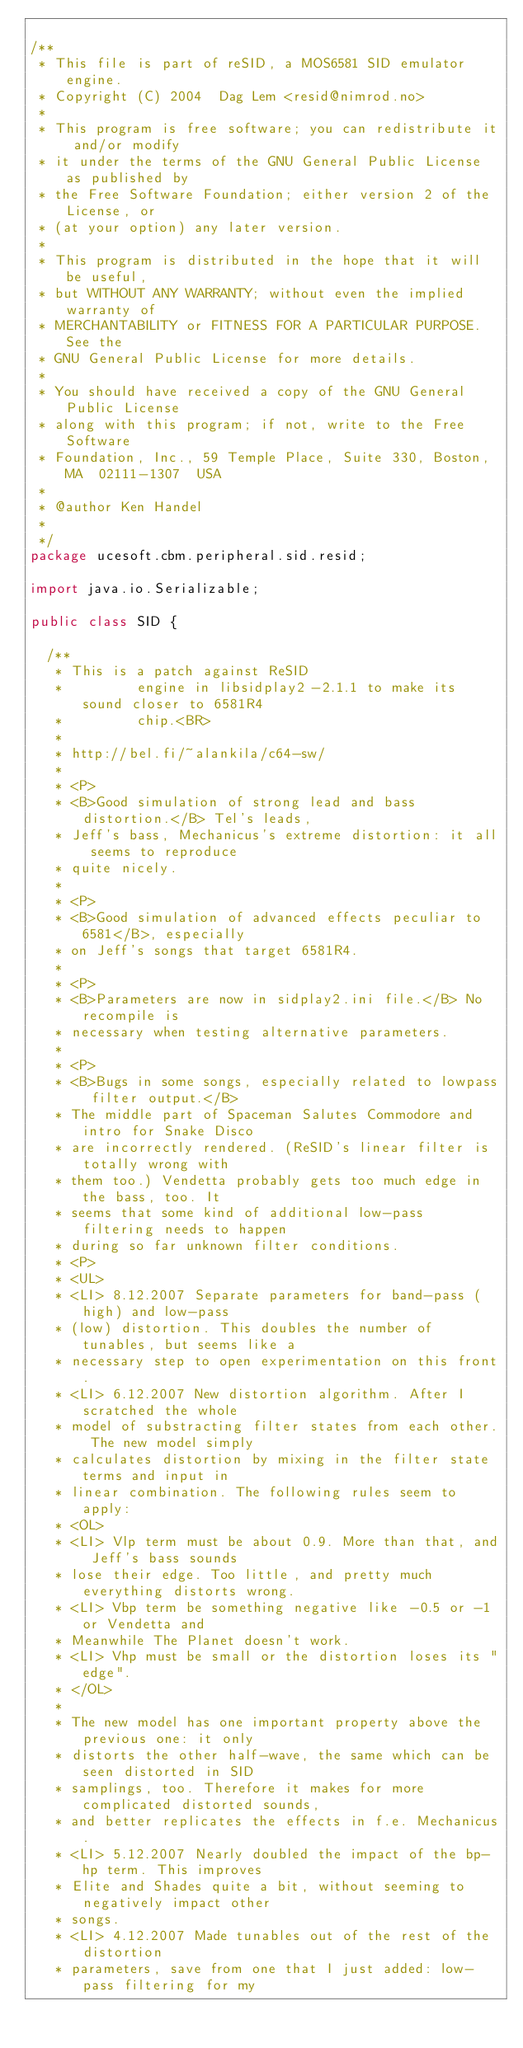Convert code to text. <code><loc_0><loc_0><loc_500><loc_500><_Java_>
/**
 * This file is part of reSID, a MOS6581 SID emulator engine.
 * Copyright (C) 2004  Dag Lem <resid@nimrod.no>
 *
 * This program is free software; you can redistribute it and/or modify
 * it under the terms of the GNU General Public License as published by
 * the Free Software Foundation; either version 2 of the License, or
 * (at your option) any later version.
 *
 * This program is distributed in the hope that it will be useful,
 * but WITHOUT ANY WARRANTY; without even the implied warranty of
 * MERCHANTABILITY or FITNESS FOR A PARTICULAR PURPOSE.  See the
 * GNU General Public License for more details.
 *
 * You should have received a copy of the GNU General Public License
 * along with this program; if not, write to the Free Software
 * Foundation, Inc., 59 Temple Place, Suite 330, Boston, MA  02111-1307  USA
 * 
 * @author Ken Handel
 *
 */
package ucesoft.cbm.peripheral.sid.resid;

import java.io.Serializable;

public class SID {

	/**
	 * This is a patch against ReSID
	 *         engine in libsidplay2-2.1.1 to make its sound closer to 6581R4
	 *         chip.<BR>
	 * 
	 * http://bel.fi/~alankila/c64-sw/
	 * 
	 * <P>
	 * <B>Good simulation of strong lead and bass distortion.</B> Tel's leads,
	 * Jeff's bass, Mechanicus's extreme distortion: it all seems to reproduce
	 * quite nicely.
	 * 
	 * <P>
	 * <B>Good simulation of advanced effects peculiar to 6581</B>, especially
	 * on Jeff's songs that target 6581R4.
	 * 
	 * <P>
	 * <B>Parameters are now in sidplay2.ini file.</B> No recompile is
	 * necessary when testing alternative parameters.
	 * 
	 * <P>
	 * <B>Bugs in some songs, especially related to lowpass filter output.</B>
	 * The middle part of Spaceman Salutes Commodore and intro for Snake Disco
	 * are incorrectly rendered. (ReSID's linear filter is totally wrong with
	 * them too.) Vendetta probably gets too much edge in the bass, too. It
	 * seems that some kind of additional low-pass filtering needs to happen
	 * during so far unknown filter conditions.
	 * <P>
	 * <UL>
	 * <LI> 8.12.2007 Separate parameters for band-pass (high) and low-pass
	 * (low) distortion. This doubles the number of tunables, but seems like a
	 * necessary step to open experimentation on this front.
	 * <LI> 6.12.2007 New distortion algorithm. After I scratched the whole
	 * model of substracting filter states from each other. The new model simply
	 * calculates distortion by mixing in the filter state terms and input in
	 * linear combination. The following rules seem to apply:
	 * <OL>
	 * <LI> Vlp term must be about 0.9. More than that, and Jeff's bass sounds
	 * lose their edge. Too little, and pretty much everything distorts wrong.
	 * <LI> Vbp term be something negative like -0.5 or -1 or Vendetta and
	 * Meanwhile The Planet doesn't work.
	 * <LI> Vhp must be small or the distortion loses its "edge".
	 * </OL>
	 * 
	 * The new model has one important property above the previous one: it only
	 * distorts the other half-wave, the same which can be seen distorted in SID
	 * samplings, too. Therefore it makes for more complicated distorted sounds,
	 * and better replicates the effects in f.e. Mechanicus.
	 * <LI> 5.12.2007 Nearly doubled the impact of the bp-hp term. This improves
	 * Elite and Shades quite a bit, without seeming to negatively impact other
	 * songs.
	 * <LI> 4.12.2007 Made tunables out of the rest of the distortion
	 * parameters, save from one that I just added: low-pass filtering for my</code> 